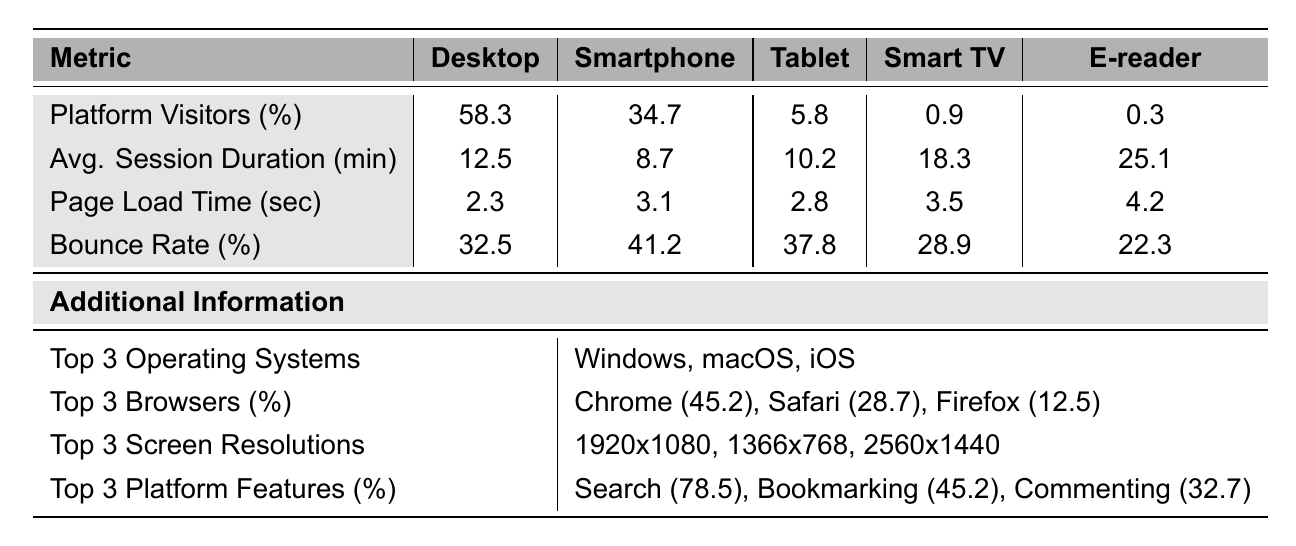What percentage of platform visitors use smartphones? The table indicates the percentage of platform visitors by device type. For smartphones, the value is specified as 34.7%.
Answer: 34.7% What is the average session duration for users on Smart TVs? The average session duration for Smart TVs is listed in the table as 18.3 minutes.
Answer: 18.3 minutes Which device type has the highest bounce rate? The bounce rates for different device types are provided. The highest bounce rate can be found by comparing the values: Desktop (32.5%), Smartphone (41.2%), Tablet (37.8%), Smart TV (28.9%), and E-reader (22.3%). The highest rate is for smartphones at 41.2%.
Answer: Smartphone What is the average page load time for all devices? To find the average page load time, we sum the load times for all devices: 2.3 + 3.1 + 2.8 + 3.5 + 4.2 = 15.9 seconds. Then, we divide by the number of devices (5) to get the average: 15.9 / 5 = 3.18 seconds.
Answer: 3.18 seconds Which device type has the lowest percentage of platform visitors? In the table, the percentage of platform visitors for each device is listed. Comparing these values, E-readers have the lowest percentage at 0.3%.
Answer: E-reader Is the average session duration for smartphones greater than that of tablets? The average session durations provided in the table are 8.7 minutes for smartphones and 10.2 minutes for tablets. Since 8.7 is less than 10.2, the statement is false.
Answer: No What is the difference in bounce rates between desktop and tablet users? The bounce rates are 32.5% for desktops and 37.8% for tablets. To find the difference, we subtract: 37.8 - 32.5 = 5.3%.
Answer: 5.3% Which platform feature is used the most, according to the table? The platform features usage percentages are given, and the highest value is for the feature "Search" at 78.5%.
Answer: Search What is the total bounce rate for smartphones and tablets combined? To find the total bounce rate for these two device types, we add their individual rates: 41.2% (smartphones) + 37.8% (tablets) = 79%.
Answer: 79% Which device has the highest average session duration? The values for average session duration for each device type are compared. The E-reader has the highest average session duration at 25.1 minutes.
Answer: E-reader 